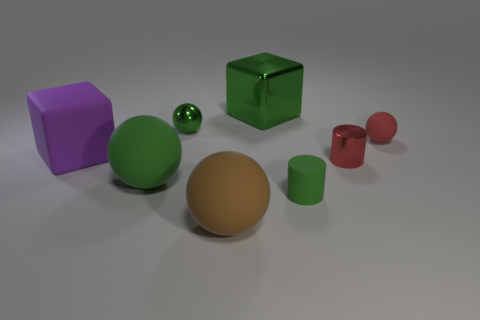What is the shape of the green rubber thing that is the same size as the brown rubber ball? The green rubber object that matches the size of the brown rubber ball is a sphere, similar to a small, glossy green ball often seen in children's toy sets. 